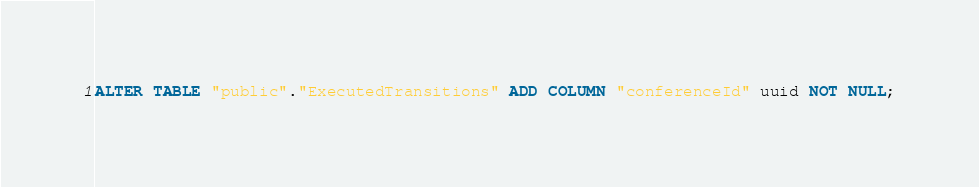<code> <loc_0><loc_0><loc_500><loc_500><_SQL_>ALTER TABLE "public"."ExecutedTransitions" ADD COLUMN "conferenceId" uuid NOT NULL;
</code> 